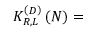<formula> <loc_0><loc_0><loc_500><loc_500>K _ { R , L } ^ { \left ( D \right ) } \left ( N \right ) =</formula> 